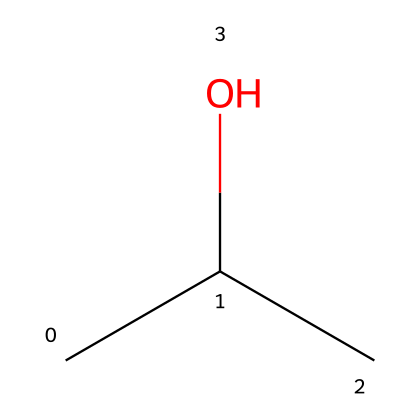What is the common name for the chemical represented by the SMILES CC(C)O? The SMILES notation indicates a branched alcohol with three carbon atoms and a hydroxyl (-OH) group, which is commonly known as isopropanol or rubbing alcohol.
Answer: isopropanol How many carbon atoms are present in this chemical structure? By examining the SMILES, "CC(C)" indicates three carbon atoms in total: two in the first part "CC" and one from the branch "C".
Answer: three What type of functional group is present in this molecule? The presence of the "-OH" group suggests that this chemical has a hydroxyl functional group, characteristic of alcohols.
Answer: hydroxyl Is this molecule considered flammable? Alcohols, including isopropanol, are categorized as flammable liquids due to their ability to ignite when exposed to an open flame.
Answer: yes What is the molecular formula for this compound? The structure can be deduced from the SMILES, showing three carbon atoms (C), eight hydrogen atoms (H), and one oxygen atom (O), resulting in the molecular formula C3H8O.
Answer: C3H8O Which specific property of this alcohol makes it useful for sports injuries? The ability of isopropanol to evaporate quickly upon application provides a cooling effect, which is beneficial in treating minor sports injuries.
Answer: cooling effect 